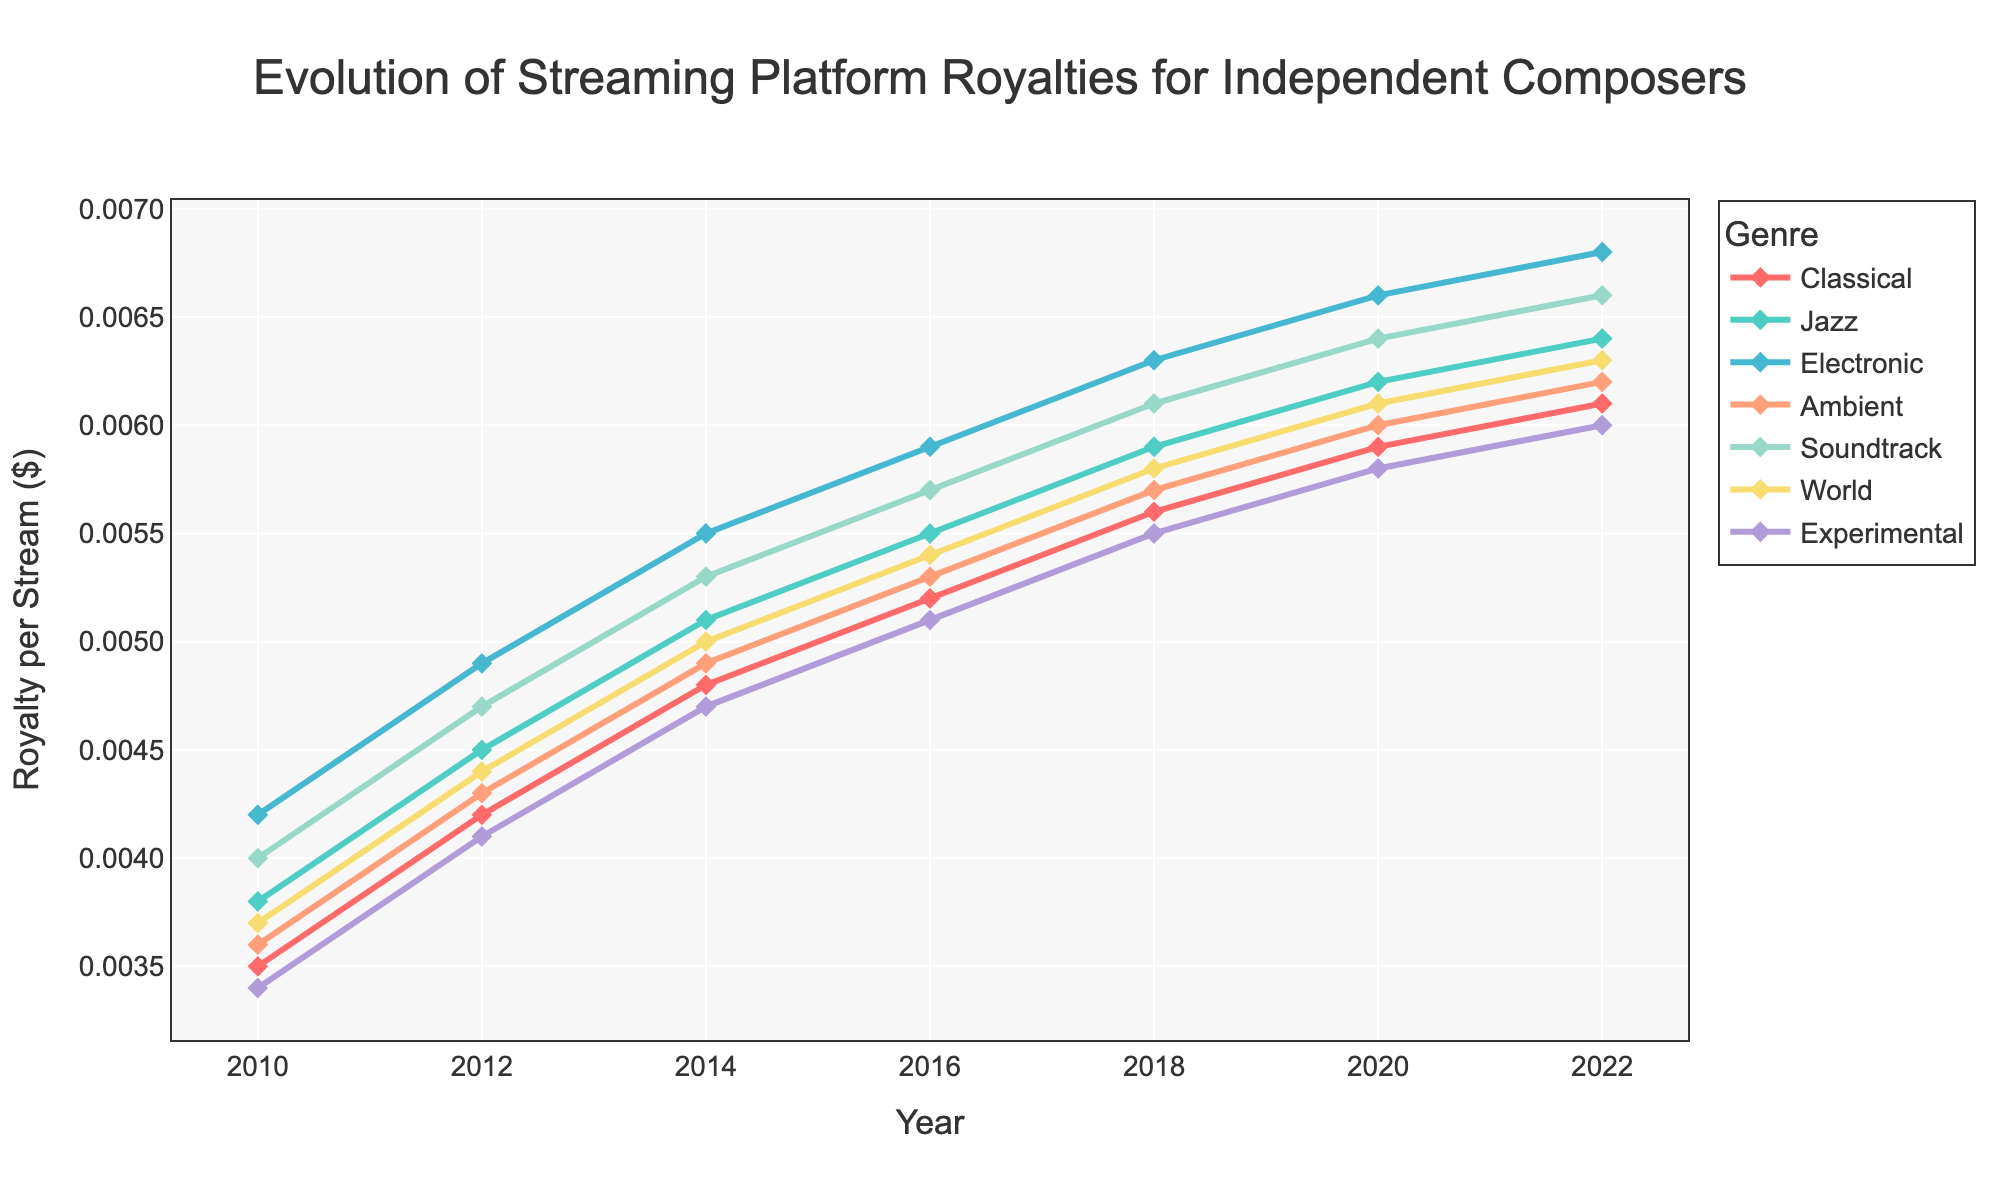Which genre had the highest increase in royalty per stream from 2010 to 2022? To determine the genre with the highest increase, we need to calculate the difference in royalties per stream for each genre between 2010 and 2022. For Classical, it is 0.0061 - 0.0035 = 0.0026. For Jazz, it is 0.0064 - 0.0038 = 0.0026. For Electronic, it is 0.0068 - 0.0042 = 0.0026. For Ambient, it is 0.0062 - 0.0036 = 0.0026. For Soundtrack, it is 0.0066 - 0.0040 = 0.0026. For World, it is 0.0063 - 0.0037 = 0.0026. For Experimental, it is 0.0060 - 0.0034 = 0.0026. Therefore, all genres had the same increase of 0.0026.
Answer: All genres had the same increase of 0.0026 Which genre had the highest royalty per stream in 2022? We need to look at the royalty per stream values for each genre in 2022: Classical (0.0061), Jazz (0.0064), Electronic (0.0068), Ambient (0.0062), Soundtrack (0.0066), World (0.0063), Experimental (0.0060). The highest value is 0.0068 for Electronic.
Answer: Electronic Which two genres had the closest royalty per stream in 2016? We compare the royalties per stream in 2016 for all genres. The values are: Classical (0.0052), Jazz (0.0055), Electronic (0.0059), Ambient (0.0053), Soundtrack (0.0057), World (0.0054), Experimental (0.0051). The closest values are 0.0055 (Jazz) and 0.0054 (World) with a difference of 0.0001.
Answer: Jazz and World What was the average royalty per stream across all genres in 2018? Summing the 2018 royalties: 0.0056 (Classical) + 0.0059 (Jazz) + 0.0063 (Electronic) + 0.0057 (Ambient) + 0.0061 (Soundtrack) + 0.0058 (World) + 0.0055 (Experimental) = 0.0419. There are 7 genres, so the average is 0.0419 / 7 = 0.00599.
Answer: 0.00599 Which genre showed the least increase in royalties from 2010 to 2020? Calculating the increase: Classical (0.0059 - 0.0035 = 0.0024), Jazz (0.0062 - 0.0038 = 0.0024), Electronic (0.0066 - 0.0042 = 0.0024), Ambient (0.0060 - 0.0036 = 0.0024), Soundtrack (0.0064 - 0.0040 = 0.0024), World (0.0061 - 0.0037 = 0.0024), Experimental (0.0058 - 0.0034 = 0.0024). All genres had the same increase of 0.0024.
Answer: All genres had the same increase of 0.0024 In which year did the Jazz genre experience the highest year-over-year increase in royalties? Analyzing the increments for Jazz: from 2010 to 2012 (0.0045 - 0.0038 = 0.0007), 2012 to 2014 (0.0051 - 0.0045 = 0.0006), 2014 to 2016 (0.0055 - 0.0051 = 0.0004), 2016 to 2018 (0.0059 - 0.0055 = 0.0004), 2018 to 2020 (0.0062 - 0.0059 = 0.0003), 2020 to 2022 (0.0064 - 0.0062 = 0.0002). The highest increase was 0.0007 between 2010 and 2012.
Answer: 2010 to 2012 Which genres had overlapping royalty per stream values at any point in time? Analyzing the data for overlapping values: In 2016, Jazz (0.0055) and World (0.0054) were very close. In 2018, Classical (0.0056) and World (0.0058) were close. In 2020, Jazz (0.0062), and World (0.0061) were close. No exact overlaps were found, only close values.
Answer: No exact overlaps, only close values Across all years, which genre had the most consistently increasing royalties? To determine consistency, we observe yearly changes without any decrease. Classical increased: (0.0042, 0.0048, 0.0052, 0.0056, 0.0059, 0.0061). Similarly, Jazz, Electronic, Ambient, Soundtrack, World, and Experimental also show consistent yearly increases. Thus, all genres had consistent increases.
Answer: All genres had consistent increases What is the difference in royalty per stream between the highest and lowest genres in 2022? To find the difference, look at the 2022 values: highest is Electronic (0.0068), lowest is Experimental (0.0060). The difference is 0.0068 - 0.0060 = 0.0008.
Answer: 0.0008 